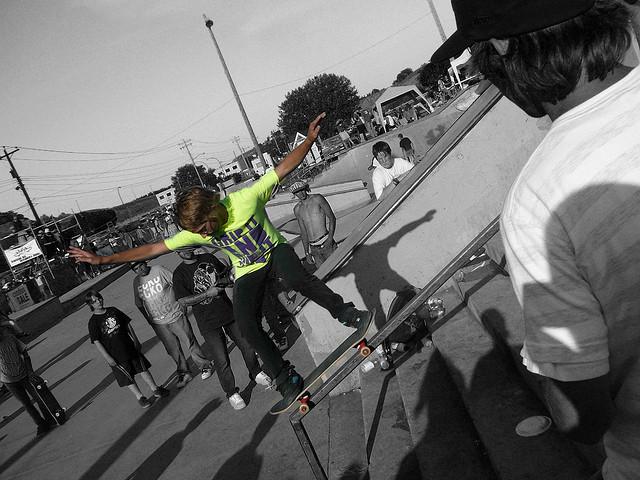What color is the skateboarders shirt?
Keep it brief. Yellow. How many stairs are visible?
Write a very short answer. 5. How many on a skateboard?
Quick response, please. 1. How many people?
Write a very short answer. 8. What are the people doing?
Short answer required. Skateboarding. 